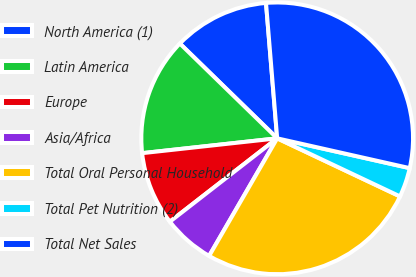Convert chart. <chart><loc_0><loc_0><loc_500><loc_500><pie_chart><fcel>North America (1)<fcel>Latin America<fcel>Europe<fcel>Asia/Africa<fcel>Total Oral Personal Household<fcel>Total Pet Nutrition (2)<fcel>Total Net Sales<nl><fcel>11.4%<fcel>14.03%<fcel>8.77%<fcel>6.14%<fcel>26.32%<fcel>3.51%<fcel>29.83%<nl></chart> 